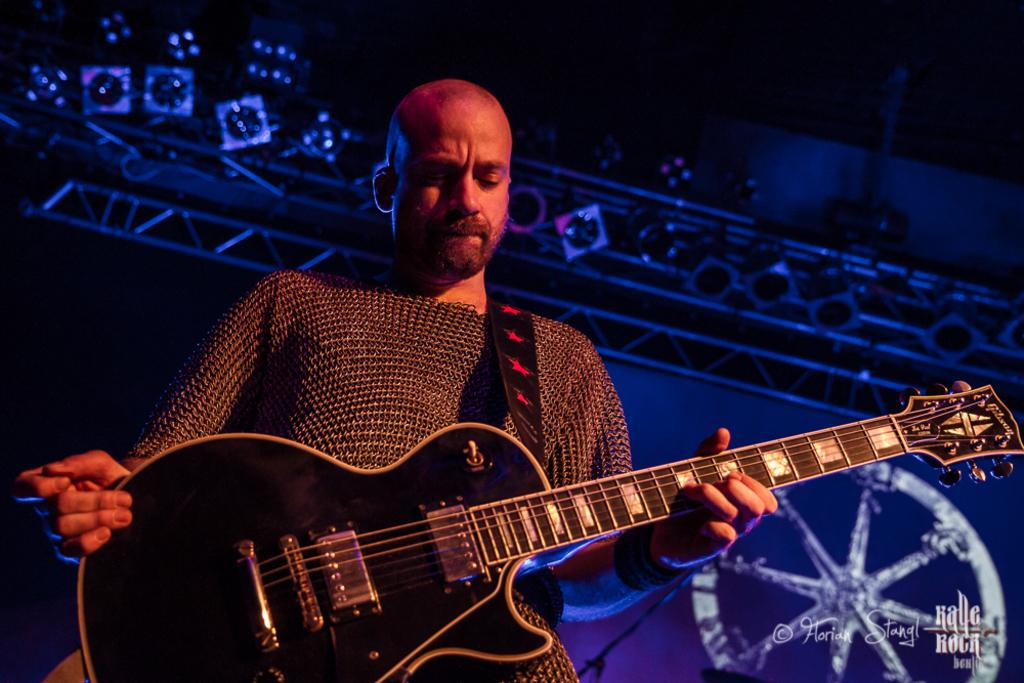What is the main subject of the image? There is a person in the image. What is the person holding in the image? The person is holding a guitar. What is the color of the guitar? The guitar is black in color. What type of shoes is the bird wearing in the image? There is no bird or shoes present in the image; it features a person holding a black guitar. 